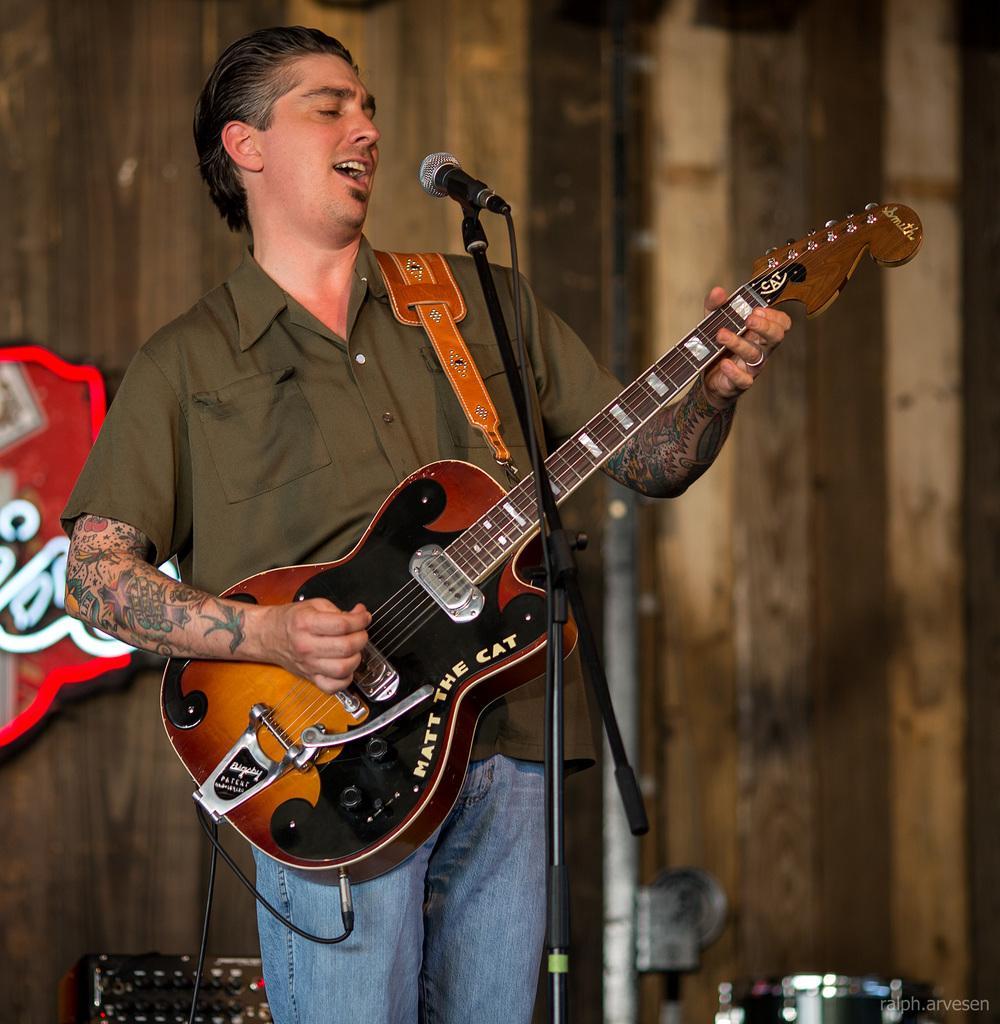Could you give a brief overview of what you see in this image? In this picture a guy is playing a guitar with a mic in front of her. In the background there is a wooden wall to which posters are attached. There is also a black sound boxes kept on either side of the image. 